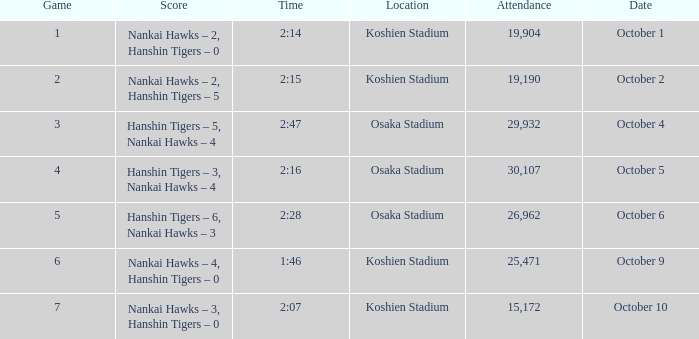How many games have an Attendance of 19,190? 1.0. 